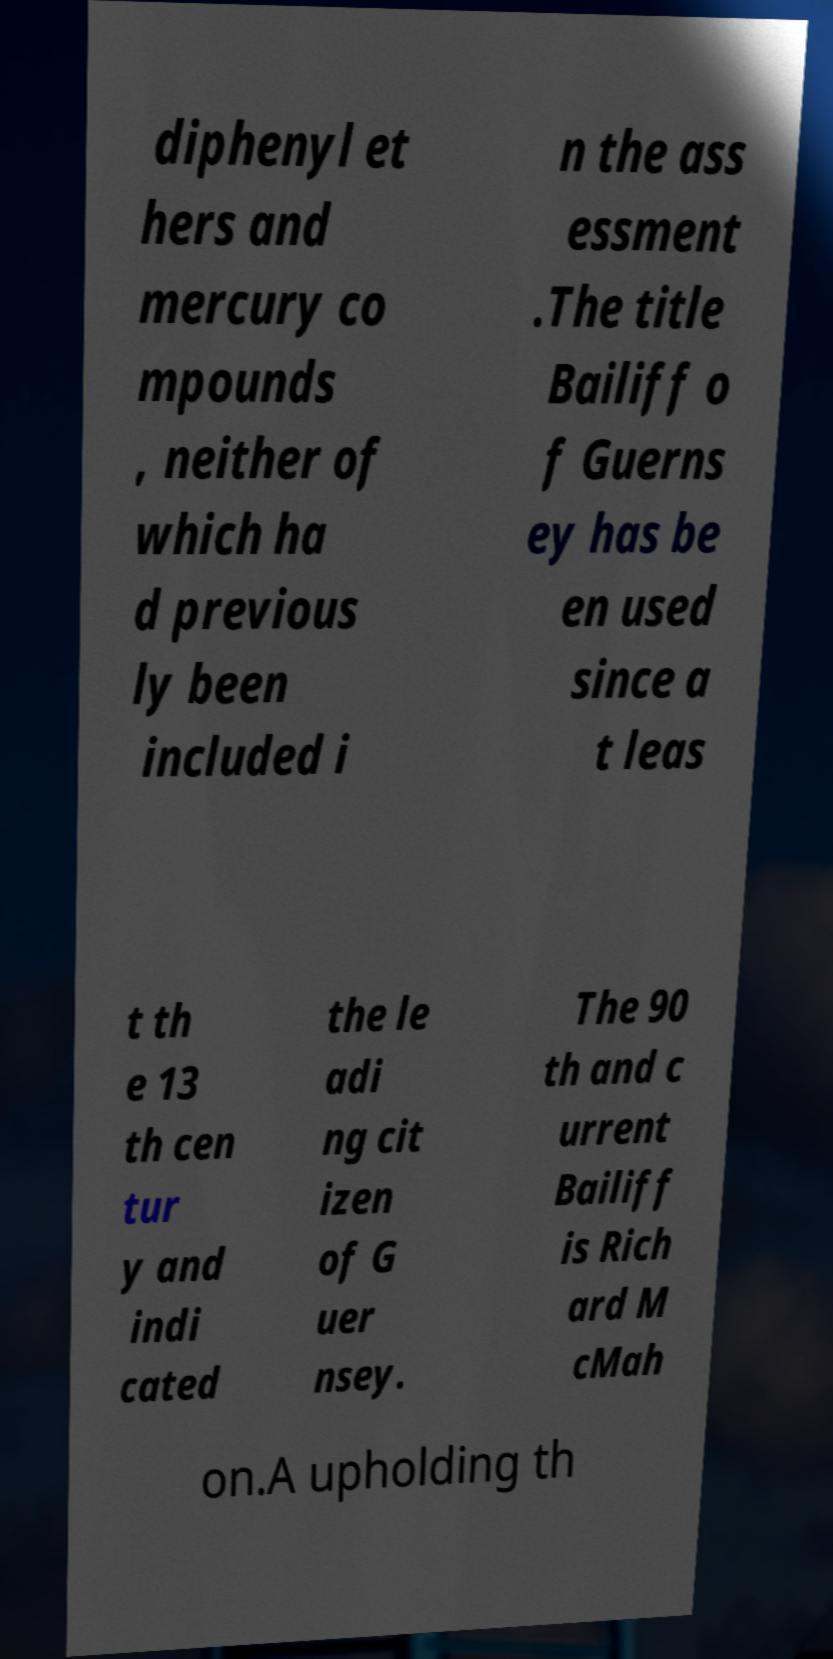I need the written content from this picture converted into text. Can you do that? diphenyl et hers and mercury co mpounds , neither of which ha d previous ly been included i n the ass essment .The title Bailiff o f Guerns ey has be en used since a t leas t th e 13 th cen tur y and indi cated the le adi ng cit izen of G uer nsey. The 90 th and c urrent Bailiff is Rich ard M cMah on.A upholding th 